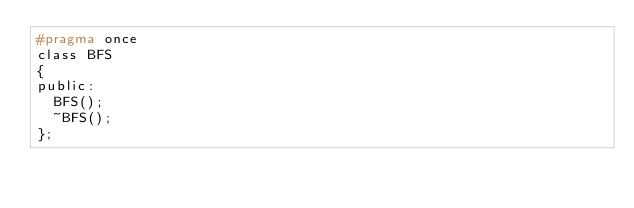Convert code to text. <code><loc_0><loc_0><loc_500><loc_500><_C_>#pragma once
class BFS
{
public:
	BFS();
	~BFS();
};

</code> 